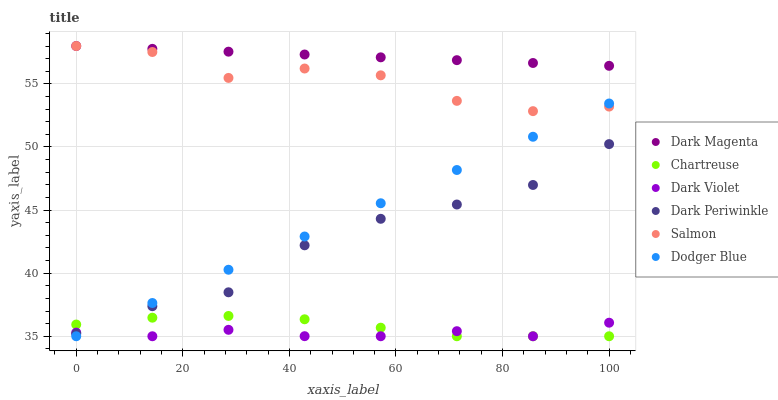Does Dark Violet have the minimum area under the curve?
Answer yes or no. Yes. Does Dark Magenta have the maximum area under the curve?
Answer yes or no. Yes. Does Salmon have the minimum area under the curve?
Answer yes or no. No. Does Salmon have the maximum area under the curve?
Answer yes or no. No. Is Dodger Blue the smoothest?
Answer yes or no. Yes. Is Salmon the roughest?
Answer yes or no. Yes. Is Dark Violet the smoothest?
Answer yes or no. No. Is Dark Violet the roughest?
Answer yes or no. No. Does Dark Violet have the lowest value?
Answer yes or no. Yes. Does Salmon have the lowest value?
Answer yes or no. No. Does Salmon have the highest value?
Answer yes or no. Yes. Does Dark Violet have the highest value?
Answer yes or no. No. Is Dark Periwinkle less than Salmon?
Answer yes or no. Yes. Is Salmon greater than Dark Periwinkle?
Answer yes or no. Yes. Does Dodger Blue intersect Salmon?
Answer yes or no. Yes. Is Dodger Blue less than Salmon?
Answer yes or no. No. Is Dodger Blue greater than Salmon?
Answer yes or no. No. Does Dark Periwinkle intersect Salmon?
Answer yes or no. No. 